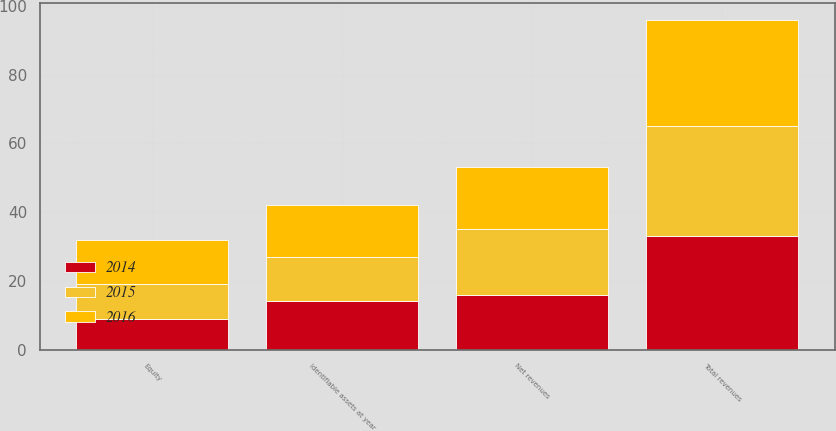Convert chart to OTSL. <chart><loc_0><loc_0><loc_500><loc_500><stacked_bar_chart><ecel><fcel>Total revenues<fcel>Net revenues<fcel>Identifiable assets at year<fcel>Equity<nl><fcel>2016<fcel>31<fcel>18<fcel>15<fcel>13<nl><fcel>2015<fcel>32<fcel>19<fcel>13<fcel>10<nl><fcel>2014<fcel>33<fcel>16<fcel>14<fcel>9<nl></chart> 